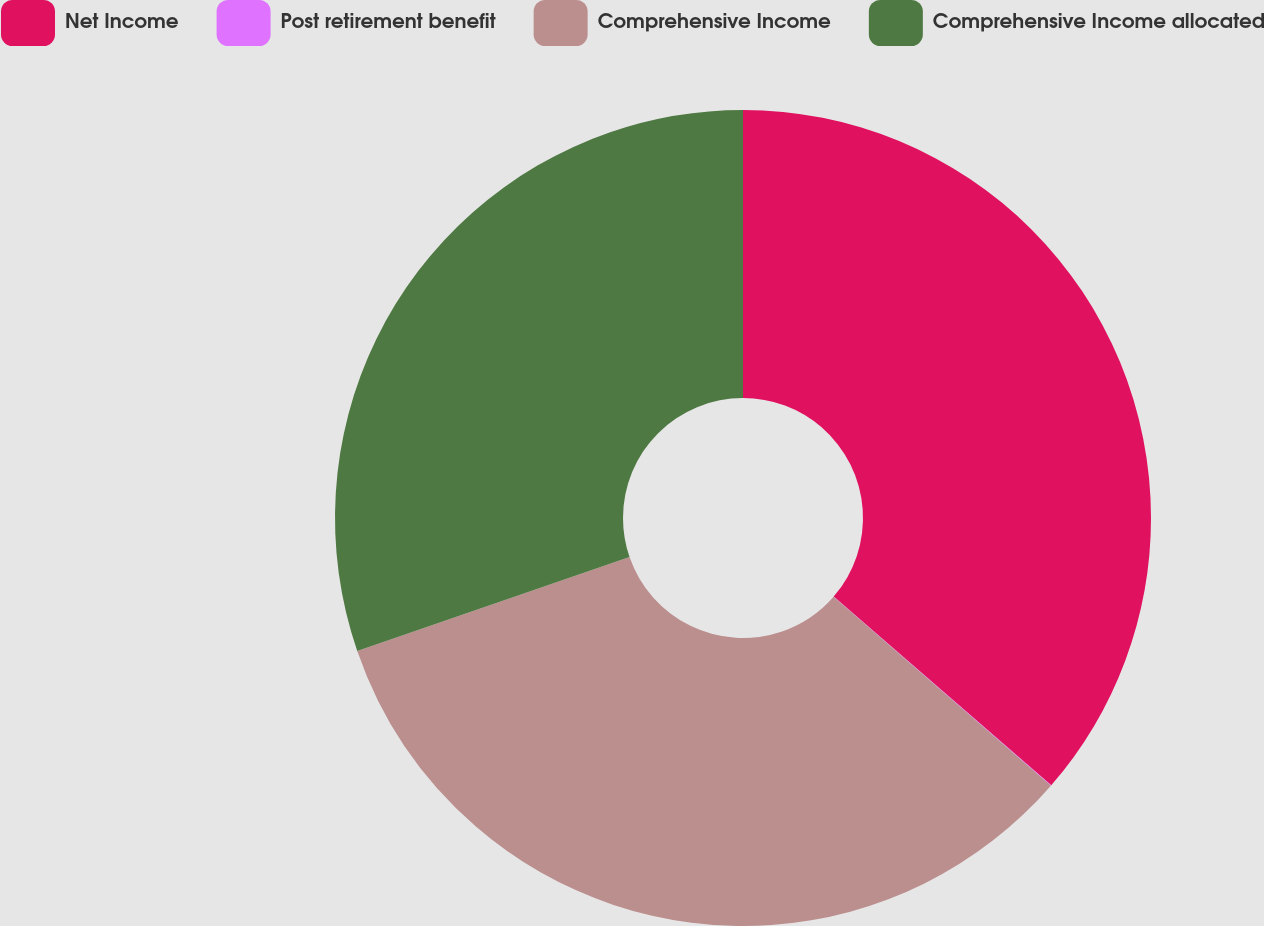<chart> <loc_0><loc_0><loc_500><loc_500><pie_chart><fcel>Net Income<fcel>Post retirement benefit<fcel>Comprehensive Income<fcel>Comprehensive Income allocated<nl><fcel>36.37%<fcel>0.02%<fcel>33.33%<fcel>30.28%<nl></chart> 